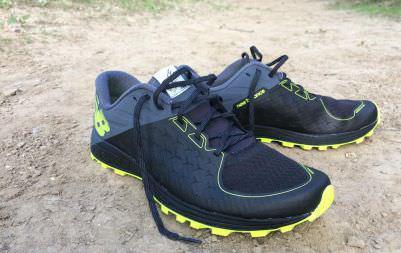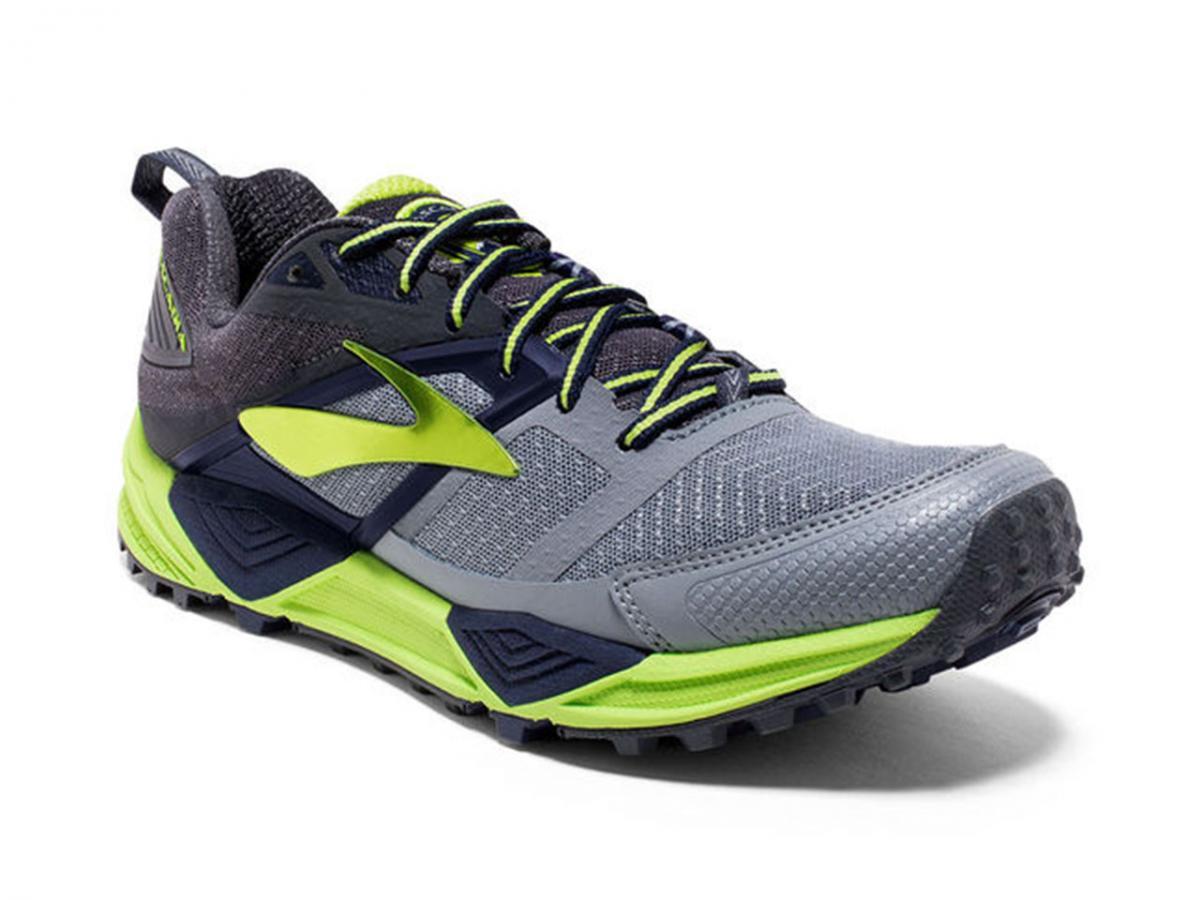The first image is the image on the left, the second image is the image on the right. For the images shown, is this caption "There is a running show with a yellow sole facing up." true? Answer yes or no. No. The first image is the image on the left, the second image is the image on the right. Evaluate the accuracy of this statement regarding the images: "the left image has one shoe pointing to the right". Is it true? Answer yes or no. No. 